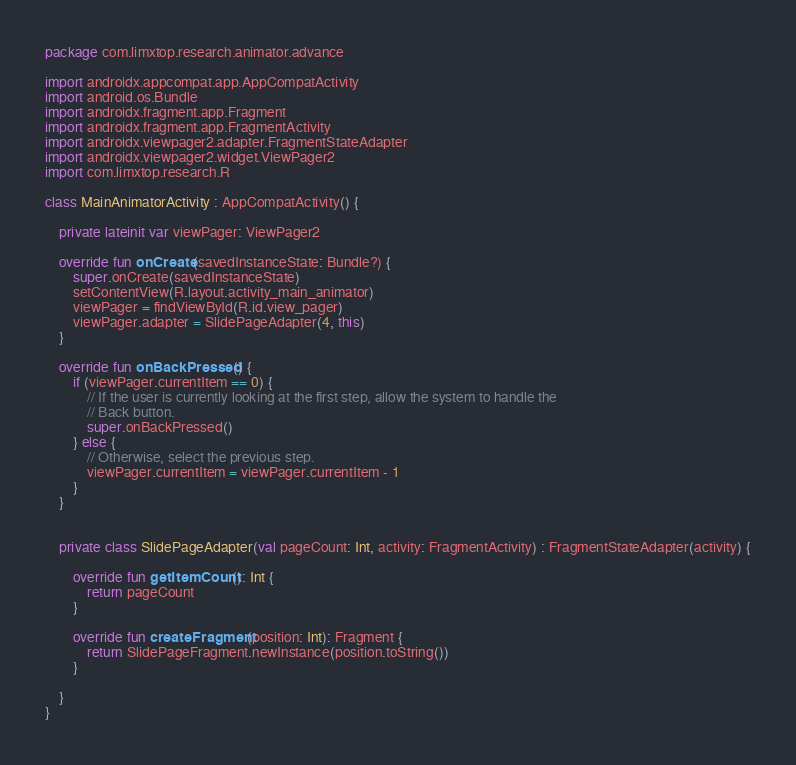Convert code to text. <code><loc_0><loc_0><loc_500><loc_500><_Kotlin_>package com.limxtop.research.animator.advance

import androidx.appcompat.app.AppCompatActivity
import android.os.Bundle
import androidx.fragment.app.Fragment
import androidx.fragment.app.FragmentActivity
import androidx.viewpager2.adapter.FragmentStateAdapter
import androidx.viewpager2.widget.ViewPager2
import com.limxtop.research.R

class MainAnimatorActivity : AppCompatActivity() {

    private lateinit var viewPager: ViewPager2

    override fun onCreate(savedInstanceState: Bundle?) {
        super.onCreate(savedInstanceState)
        setContentView(R.layout.activity_main_animator)
        viewPager = findViewById(R.id.view_pager)
        viewPager.adapter = SlidePageAdapter(4, this)
    }

    override fun onBackPressed() {
        if (viewPager.currentItem == 0) {
            // If the user is currently looking at the first step, allow the system to handle the
            // Back button.
            super.onBackPressed()
        } else {
            // Otherwise, select the previous step.
            viewPager.currentItem = viewPager.currentItem - 1
        }
    }


    private class SlidePageAdapter(val pageCount: Int, activity: FragmentActivity) : FragmentStateAdapter(activity) {

        override fun getItemCount(): Int {
            return pageCount
        }

        override fun createFragment(position: Int): Fragment {
            return SlidePageFragment.newInstance(position.toString())
        }

    }
}</code> 